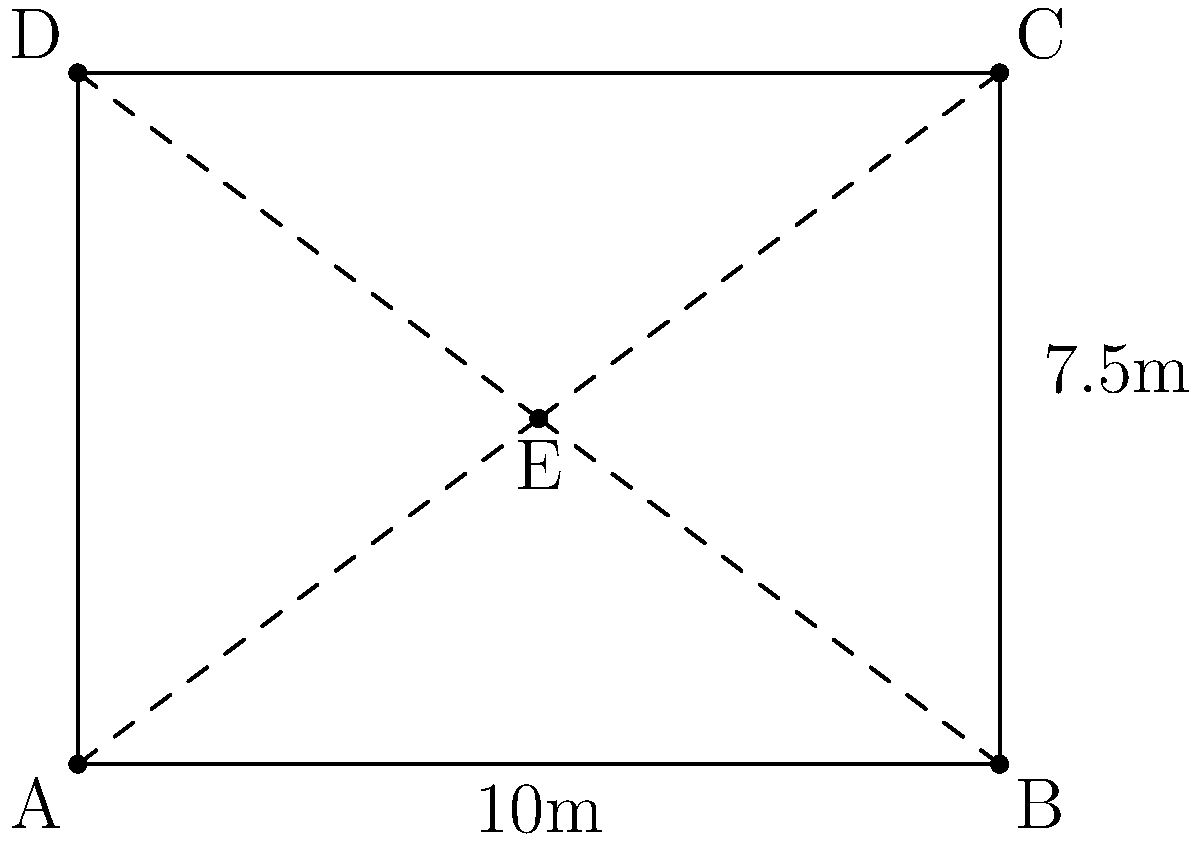In a rectangular event space measuring 10m by 7.5m, a central chocolate station is set up at point E. Servers need to distribute chocolates from E to the four corners (A, B, C, D) of the room. What is the total distance a server would travel to visit all four corners and return to E, following the most efficient path? To solve this problem, we'll follow these steps:

1) First, we need to calculate the coordinates of point E. Given the room dimensions:
   E is at (5, 3.75) in meters from the origin (A).

2) Now, we can calculate the distances from E to each corner using the distance formula:
   $d = \sqrt{(x_2-x_1)^2 + (y_2-y_1)^2}$

   EA = $\sqrt{(0-5)^2 + (0-3.75)^2} = \sqrt{25 + 14.0625} = \sqrt{39.0625} = 6.25$ m
   EB = $\sqrt{(10-5)^2 + (0-3.75)^2} = \sqrt{25 + 14.0625} = \sqrt{39.0625} = 6.25$ m
   EC = $\sqrt{(10-5)^2 + (7.5-3.75)^2} = \sqrt{25 + 14.0625} = \sqrt{39.0625} = 6.25$ m
   ED = $\sqrt{(0-5)^2 + (7.5-3.75)^2} = \sqrt{25 + 14.0625} = \sqrt{39.0625} = 6.25$ m

3) The most efficient path would be to visit all corners once and return to E. This forms a star pattern.

4) The total distance is the sum of all these distances:
   Total distance = EA + EB + EC + ED + EA = 6.25 * 5 = 31.25 m

Therefore, the most efficient path for the server would be 31.25 meters.
Answer: 31.25 m 